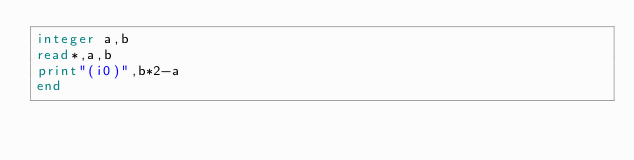<code> <loc_0><loc_0><loc_500><loc_500><_FORTRAN_>integer a,b
read*,a,b
print"(i0)",b*2-a
end</code> 